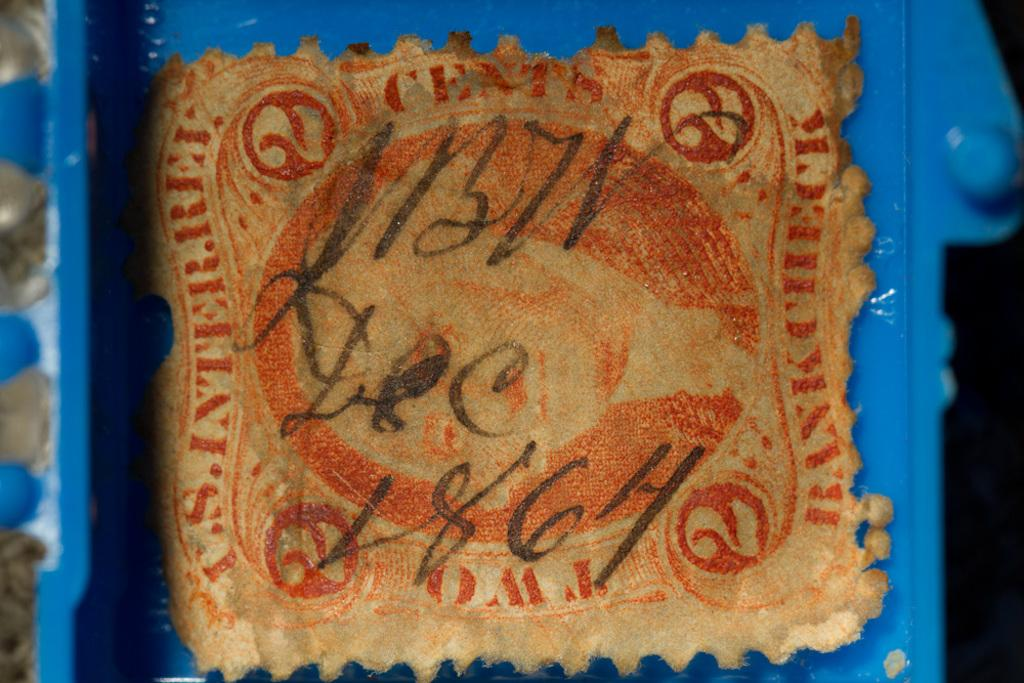What is the focus of the image? The image is zoomed in. What can be seen in the foreground of the image? There is a blue color object in the foreground. What type of material is present in the image? There is a cloth in the image. What is written on the cloth? Text is written on the cloth. Is there a notebook visible in the image? There is no mention of a notebook in the provided facts, so it cannot be confirmed whether one is present in the image. Is there a beggar asking for help in the image? There is no information about a beggar or any person in the image, so it cannot be confirmed whether one is present. 